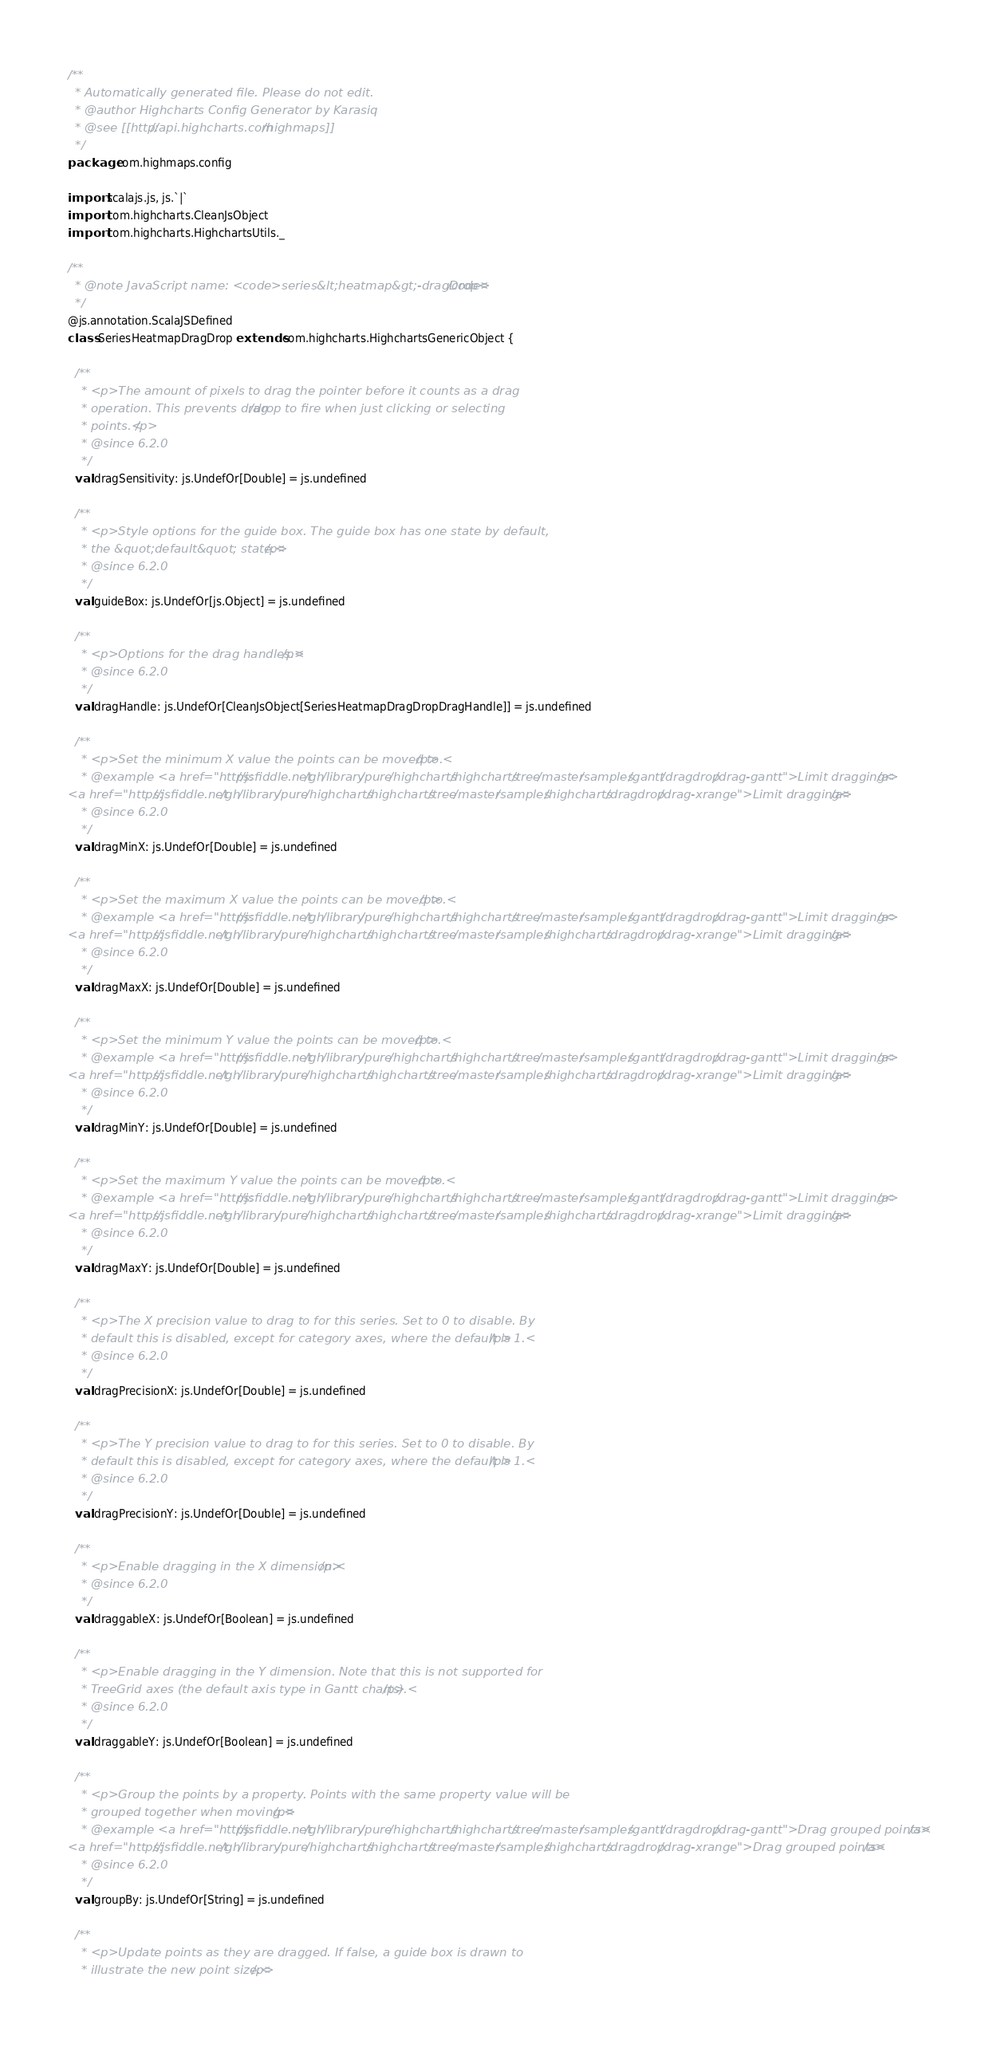<code> <loc_0><loc_0><loc_500><loc_500><_Scala_>/**
  * Automatically generated file. Please do not edit.
  * @author Highcharts Config Generator by Karasiq
  * @see [[http://api.highcharts.com/highmaps]]
  */
package com.highmaps.config

import scalajs.js, js.`|`
import com.highcharts.CleanJsObject
import com.highcharts.HighchartsUtils._

/**
  * @note JavaScript name: <code>series&lt;heatmap&gt;-dragDrop</code>
  */
@js.annotation.ScalaJSDefined
class SeriesHeatmapDragDrop extends com.highcharts.HighchartsGenericObject {

  /**
    * <p>The amount of pixels to drag the pointer before it counts as a drag
    * operation. This prevents drag/drop to fire when just clicking or selecting
    * points.</p>
    * @since 6.2.0
    */
  val dragSensitivity: js.UndefOr[Double] = js.undefined

  /**
    * <p>Style options for the guide box. The guide box has one state by default,
    * the &quot;default&quot; state.</p>
    * @since 6.2.0
    */
  val guideBox: js.UndefOr[js.Object] = js.undefined

  /**
    * <p>Options for the drag handles.</p>
    * @since 6.2.0
    */
  val dragHandle: js.UndefOr[CleanJsObject[SeriesHeatmapDragDropDragHandle]] = js.undefined

  /**
    * <p>Set the minimum X value the points can be moved to.</p>
    * @example <a href="https://jsfiddle.net/gh/library/pure/highcharts/highcharts/tree/master/samples/gantt/dragdrop/drag-gantt">Limit dragging</a>
<a href="https://jsfiddle.net/gh/library/pure/highcharts/highcharts/tree/master/samples/highcharts/dragdrop/drag-xrange">Limit dragging</a>
    * @since 6.2.0
    */
  val dragMinX: js.UndefOr[Double] = js.undefined

  /**
    * <p>Set the maximum X value the points can be moved to.</p>
    * @example <a href="https://jsfiddle.net/gh/library/pure/highcharts/highcharts/tree/master/samples/gantt/dragdrop/drag-gantt">Limit dragging</a>
<a href="https://jsfiddle.net/gh/library/pure/highcharts/highcharts/tree/master/samples/highcharts/dragdrop/drag-xrange">Limit dragging</a>
    * @since 6.2.0
    */
  val dragMaxX: js.UndefOr[Double] = js.undefined

  /**
    * <p>Set the minimum Y value the points can be moved to.</p>
    * @example <a href="https://jsfiddle.net/gh/library/pure/highcharts/highcharts/tree/master/samples/gantt/dragdrop/drag-gantt">Limit dragging</a>
<a href="https://jsfiddle.net/gh/library/pure/highcharts/highcharts/tree/master/samples/highcharts/dragdrop/drag-xrange">Limit dragging</a>
    * @since 6.2.0
    */
  val dragMinY: js.UndefOr[Double] = js.undefined

  /**
    * <p>Set the maximum Y value the points can be moved to.</p>
    * @example <a href="https://jsfiddle.net/gh/library/pure/highcharts/highcharts/tree/master/samples/gantt/dragdrop/drag-gantt">Limit dragging</a>
<a href="https://jsfiddle.net/gh/library/pure/highcharts/highcharts/tree/master/samples/highcharts/dragdrop/drag-xrange">Limit dragging</a>
    * @since 6.2.0
    */
  val dragMaxY: js.UndefOr[Double] = js.undefined

  /**
    * <p>The X precision value to drag to for this series. Set to 0 to disable. By
    * default this is disabled, except for category axes, where the default is 1.</p>
    * @since 6.2.0
    */
  val dragPrecisionX: js.UndefOr[Double] = js.undefined

  /**
    * <p>The Y precision value to drag to for this series. Set to 0 to disable. By
    * default this is disabled, except for category axes, where the default is 1.</p>
    * @since 6.2.0
    */
  val dragPrecisionY: js.UndefOr[Double] = js.undefined

  /**
    * <p>Enable dragging in the X dimension.</p>
    * @since 6.2.0
    */
  val draggableX: js.UndefOr[Boolean] = js.undefined

  /**
    * <p>Enable dragging in the Y dimension. Note that this is not supported for
    * TreeGrid axes (the default axis type in Gantt charts).</p>
    * @since 6.2.0
    */
  val draggableY: js.UndefOr[Boolean] = js.undefined

  /**
    * <p>Group the points by a property. Points with the same property value will be
    * grouped together when moving.</p>
    * @example <a href="https://jsfiddle.net/gh/library/pure/highcharts/highcharts/tree/master/samples/gantt/dragdrop/drag-gantt">Drag grouped points</a>
<a href="https://jsfiddle.net/gh/library/pure/highcharts/highcharts/tree/master/samples/highcharts/dragdrop/drag-xrange">Drag grouped points</a>
    * @since 6.2.0
    */
  val groupBy: js.UndefOr[String] = js.undefined

  /**
    * <p>Update points as they are dragged. If false, a guide box is drawn to
    * illustrate the new point size.</p></code> 